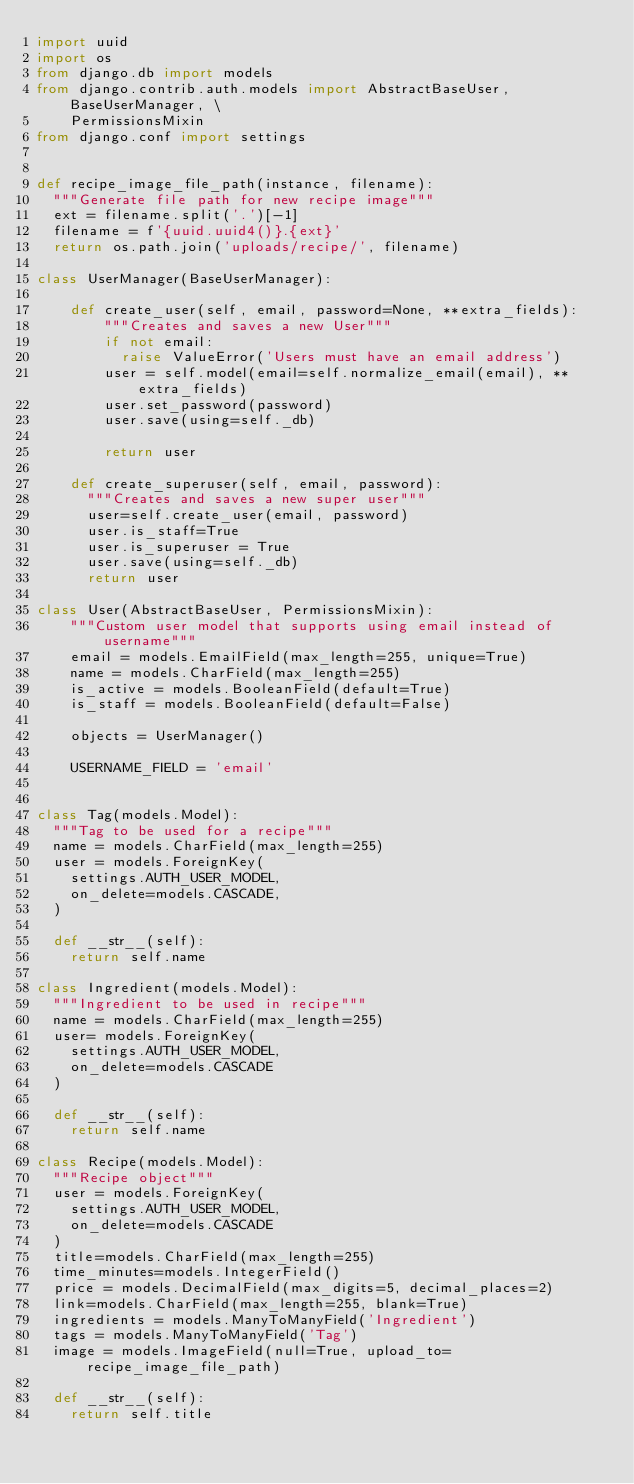Convert code to text. <code><loc_0><loc_0><loc_500><loc_500><_Python_>import uuid
import os
from django.db import models
from django.contrib.auth.models import AbstractBaseUser, BaseUserManager, \
    PermissionsMixin
from django.conf import settings


def recipe_image_file_path(instance, filename):
  """Generate file path for new recipe image"""
  ext = filename.split('.')[-1]
  filename = f'{uuid.uuid4()}.{ext}'
  return os.path.join('uploads/recipe/', filename)

class UserManager(BaseUserManager):

    def create_user(self, email, password=None, **extra_fields):
        """Creates and saves a new User"""
        if not email:
          raise ValueError('Users must have an email address')
        user = self.model(email=self.normalize_email(email), **extra_fields)
        user.set_password(password)
        user.save(using=self._db)

        return user

    def create_superuser(self, email, password):
      """Creates and saves a new super user"""
      user=self.create_user(email, password)
      user.is_staff=True
      user.is_superuser = True
      user.save(using=self._db)
      return user

class User(AbstractBaseUser, PermissionsMixin):
    """Custom user model that supports using email instead of username"""
    email = models.EmailField(max_length=255, unique=True)
    name = models.CharField(max_length=255)
    is_active = models.BooleanField(default=True)
    is_staff = models.BooleanField(default=False)

    objects = UserManager()

    USERNAME_FIELD = 'email'


class Tag(models.Model):
  """Tag to be used for a recipe"""
  name = models.CharField(max_length=255)
  user = models.ForeignKey(
    settings.AUTH_USER_MODEL,
    on_delete=models.CASCADE,
  )

  def __str__(self):
    return self.name

class Ingredient(models.Model):
  """Ingredient to be used in recipe"""
  name = models.CharField(max_length=255)
  user= models.ForeignKey(
    settings.AUTH_USER_MODEL,
    on_delete=models.CASCADE
  )

  def __str__(self):
    return self.name

class Recipe(models.Model):
  """Recipe object"""
  user = models.ForeignKey(
    settings.AUTH_USER_MODEL,
    on_delete=models.CASCADE
  )
  title=models.CharField(max_length=255)
  time_minutes=models.IntegerField()
  price = models.DecimalField(max_digits=5, decimal_places=2)
  link=models.CharField(max_length=255, blank=True)
  ingredients = models.ManyToManyField('Ingredient')
  tags = models.ManyToManyField('Tag')
  image = models.ImageField(null=True, upload_to=recipe_image_file_path)

  def __str__(self):
    return self.title
</code> 